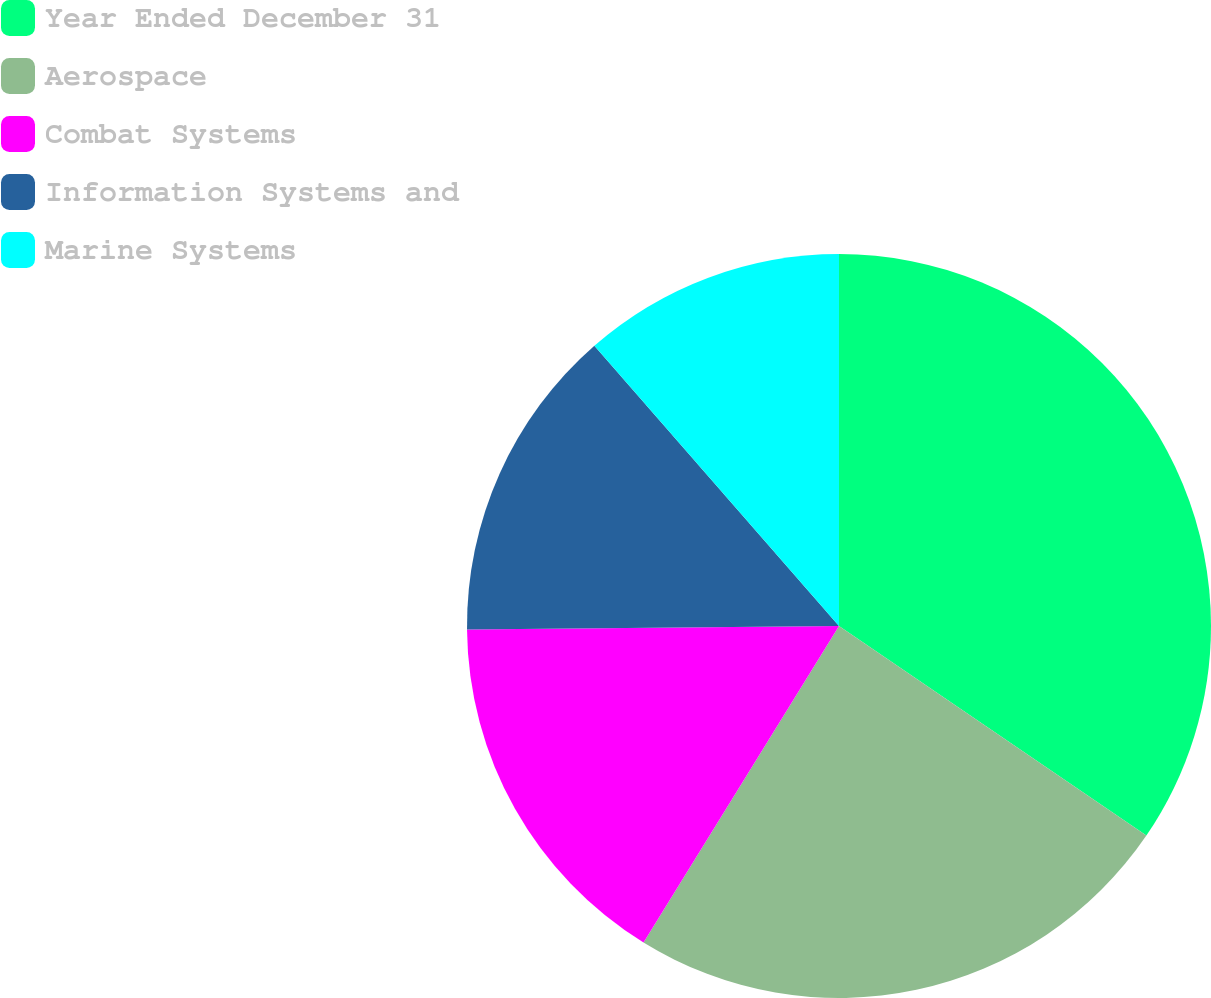Convert chart to OTSL. <chart><loc_0><loc_0><loc_500><loc_500><pie_chart><fcel>Year Ended December 31<fcel>Aerospace<fcel>Combat Systems<fcel>Information Systems and<fcel>Marine Systems<nl><fcel>34.52%<fcel>24.28%<fcel>16.04%<fcel>13.73%<fcel>11.42%<nl></chart> 